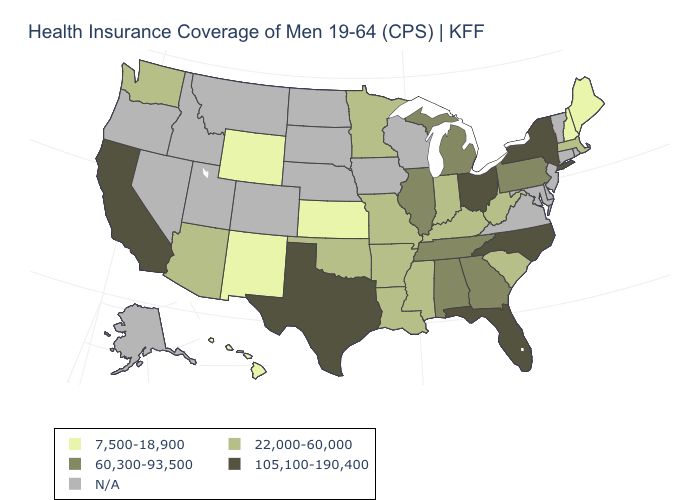What is the value of New Hampshire?
Concise answer only. 7,500-18,900. Which states have the lowest value in the South?
Give a very brief answer. Arkansas, Kentucky, Louisiana, Mississippi, Oklahoma, South Carolina, West Virginia. Does Illinois have the highest value in the MidWest?
Keep it brief. No. What is the lowest value in states that border Arkansas?
Short answer required. 22,000-60,000. Name the states that have a value in the range N/A?
Short answer required. Alaska, Colorado, Connecticut, Delaware, Idaho, Iowa, Maryland, Montana, Nebraska, Nevada, New Jersey, North Dakota, Oregon, Rhode Island, South Dakota, Utah, Vermont, Virginia, Wisconsin. Name the states that have a value in the range N/A?
Concise answer only. Alaska, Colorado, Connecticut, Delaware, Idaho, Iowa, Maryland, Montana, Nebraska, Nevada, New Jersey, North Dakota, Oregon, Rhode Island, South Dakota, Utah, Vermont, Virginia, Wisconsin. What is the value of Wisconsin?
Quick response, please. N/A. Name the states that have a value in the range 60,300-93,500?
Concise answer only. Alabama, Georgia, Illinois, Michigan, Pennsylvania, Tennessee. What is the value of Mississippi?
Concise answer only. 22,000-60,000. What is the value of Illinois?
Write a very short answer. 60,300-93,500. What is the value of South Carolina?
Write a very short answer. 22,000-60,000. 